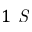<formula> <loc_0><loc_0><loc_500><loc_500>1 S</formula> 